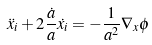Convert formula to latex. <formula><loc_0><loc_0><loc_500><loc_500>\ddot { x } _ { i } + 2 \frac { \dot { a } } { a } \dot { { x } _ { i } } = - \frac { 1 } { a ^ { 2 } } \nabla _ { x } \phi</formula> 